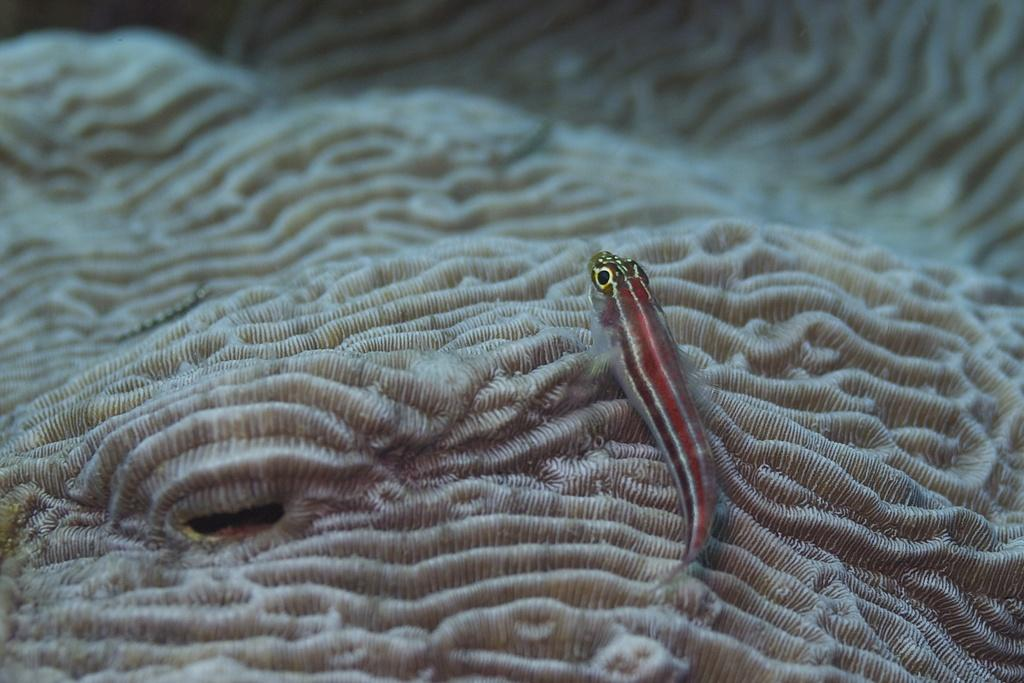What type of animal is in the image? There is a small red color fish in the image. Where is the fish located? The fish is under the sea water. What other object can be seen in the image? There is a coral stone visible in the image. How many chairs are placed around the desk in the image? There are no chairs or desks present in the image; it features a fish under the sea water and a coral stone. 